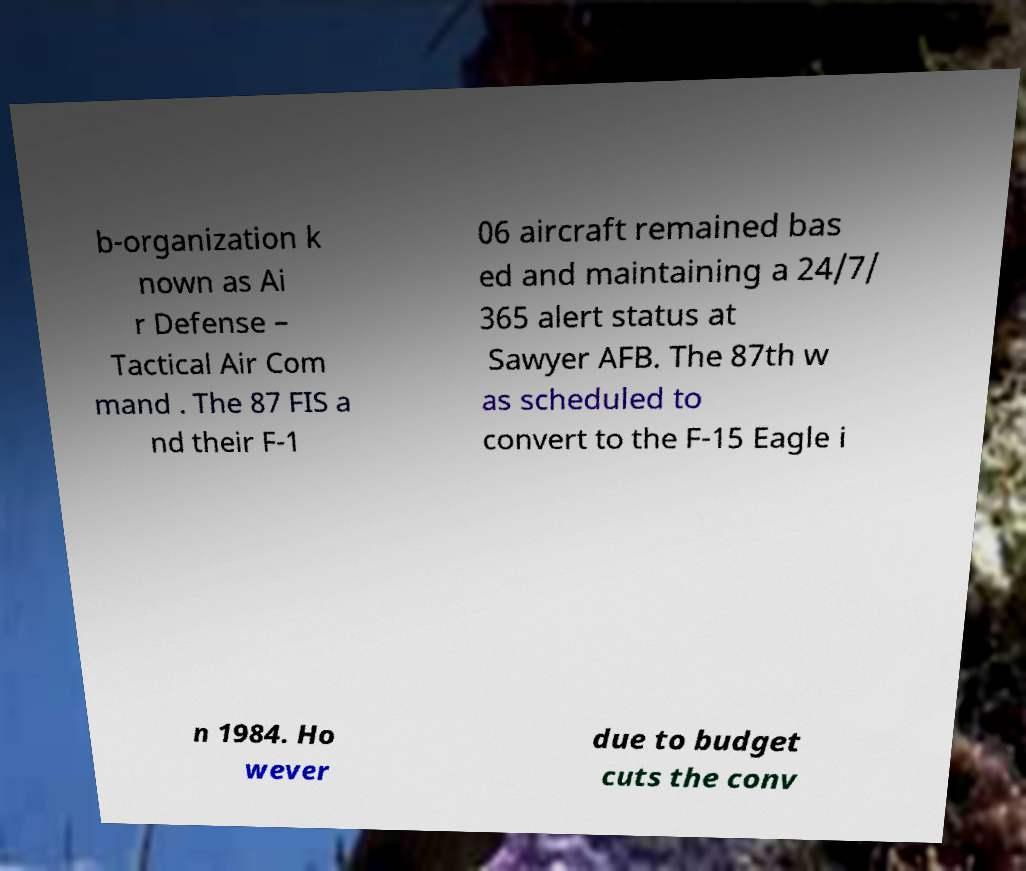Could you extract and type out the text from this image? b-organization k nown as Ai r Defense – Tactical Air Com mand . The 87 FIS a nd their F-1 06 aircraft remained bas ed and maintaining a 24/7/ 365 alert status at Sawyer AFB. The 87th w as scheduled to convert to the F-15 Eagle i n 1984. Ho wever due to budget cuts the conv 